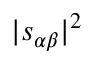Convert formula to latex. <formula><loc_0><loc_0><loc_500><loc_500>| s _ { \alpha \beta } | ^ { 2 }</formula> 